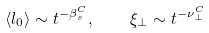Convert formula to latex. <formula><loc_0><loc_0><loc_500><loc_500>\langle l _ { 0 } \rangle \sim t ^ { - \beta _ { s } ^ { C } } , \quad \xi _ { \perp } \sim t ^ { - \nu _ { \perp } ^ { C } }</formula> 